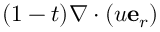Convert formula to latex. <formula><loc_0><loc_0><loc_500><loc_500>( 1 - t ) \nabla \cdot ( u e _ { r } )</formula> 